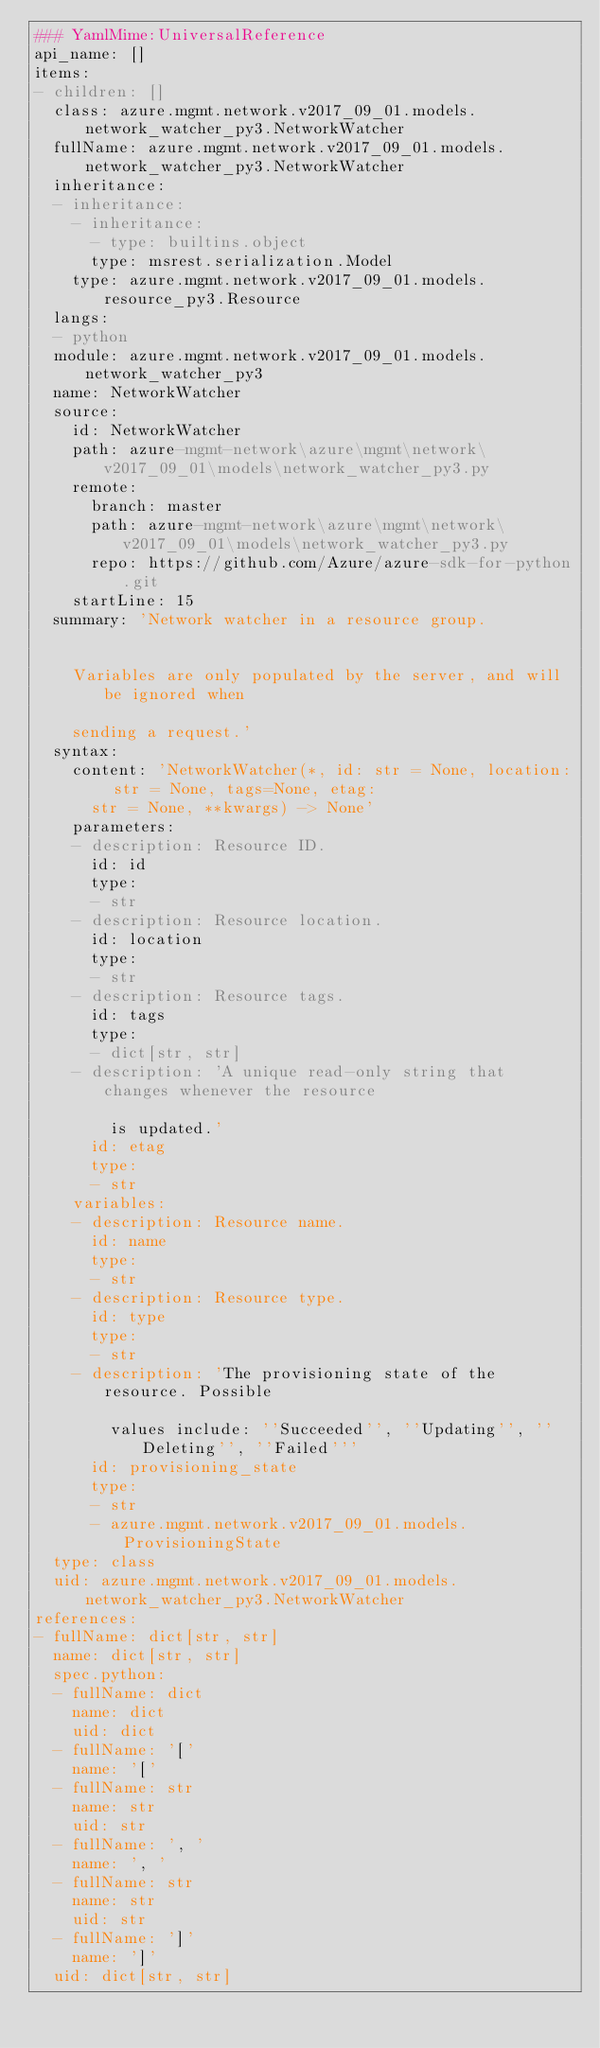Convert code to text. <code><loc_0><loc_0><loc_500><loc_500><_YAML_>### YamlMime:UniversalReference
api_name: []
items:
- children: []
  class: azure.mgmt.network.v2017_09_01.models.network_watcher_py3.NetworkWatcher
  fullName: azure.mgmt.network.v2017_09_01.models.network_watcher_py3.NetworkWatcher
  inheritance:
  - inheritance:
    - inheritance:
      - type: builtins.object
      type: msrest.serialization.Model
    type: azure.mgmt.network.v2017_09_01.models.resource_py3.Resource
  langs:
  - python
  module: azure.mgmt.network.v2017_09_01.models.network_watcher_py3
  name: NetworkWatcher
  source:
    id: NetworkWatcher
    path: azure-mgmt-network\azure\mgmt\network\v2017_09_01\models\network_watcher_py3.py
    remote:
      branch: master
      path: azure-mgmt-network\azure\mgmt\network\v2017_09_01\models\network_watcher_py3.py
      repo: https://github.com/Azure/azure-sdk-for-python.git
    startLine: 15
  summary: 'Network watcher in a resource group.


    Variables are only populated by the server, and will be ignored when

    sending a request.'
  syntax:
    content: 'NetworkWatcher(*, id: str = None, location: str = None, tags=None, etag:
      str = None, **kwargs) -> None'
    parameters:
    - description: Resource ID.
      id: id
      type:
      - str
    - description: Resource location.
      id: location
      type:
      - str
    - description: Resource tags.
      id: tags
      type:
      - dict[str, str]
    - description: 'A unique read-only string that changes whenever the resource

        is updated.'
      id: etag
      type:
      - str
    variables:
    - description: Resource name.
      id: name
      type:
      - str
    - description: Resource type.
      id: type
      type:
      - str
    - description: 'The provisioning state of the resource. Possible

        values include: ''Succeeded'', ''Updating'', ''Deleting'', ''Failed'''
      id: provisioning_state
      type:
      - str
      - azure.mgmt.network.v2017_09_01.models.ProvisioningState
  type: class
  uid: azure.mgmt.network.v2017_09_01.models.network_watcher_py3.NetworkWatcher
references:
- fullName: dict[str, str]
  name: dict[str, str]
  spec.python:
  - fullName: dict
    name: dict
    uid: dict
  - fullName: '['
    name: '['
  - fullName: str
    name: str
    uid: str
  - fullName: ', '
    name: ', '
  - fullName: str
    name: str
    uid: str
  - fullName: ']'
    name: ']'
  uid: dict[str, str]
</code> 